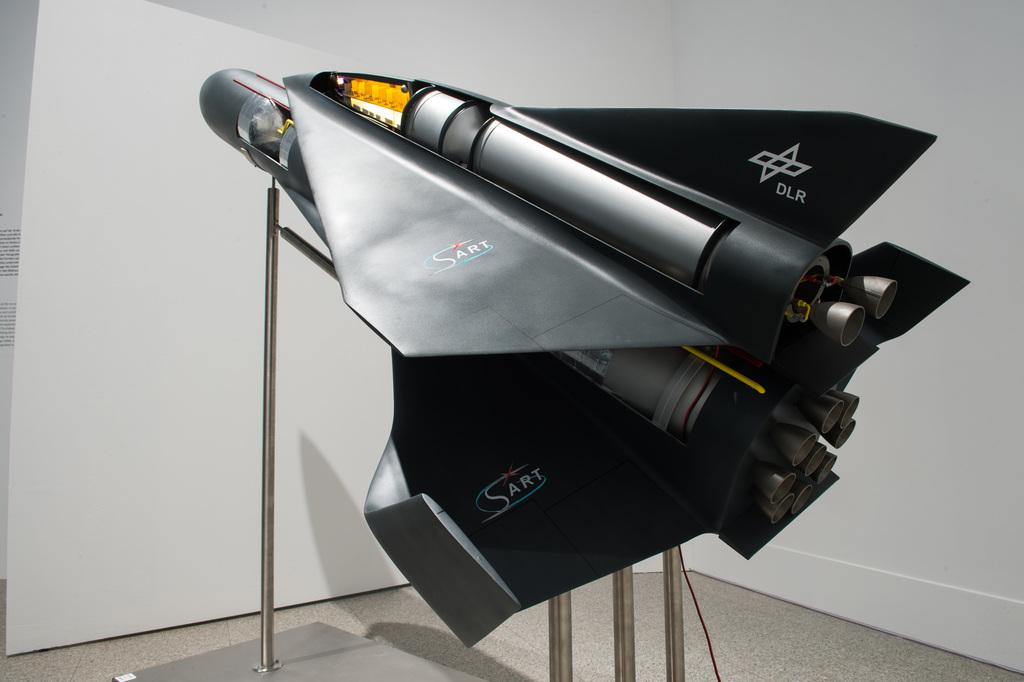<image>
Relay a brief, clear account of the picture shown. Black model aircraft with DLR printed on the tail. 